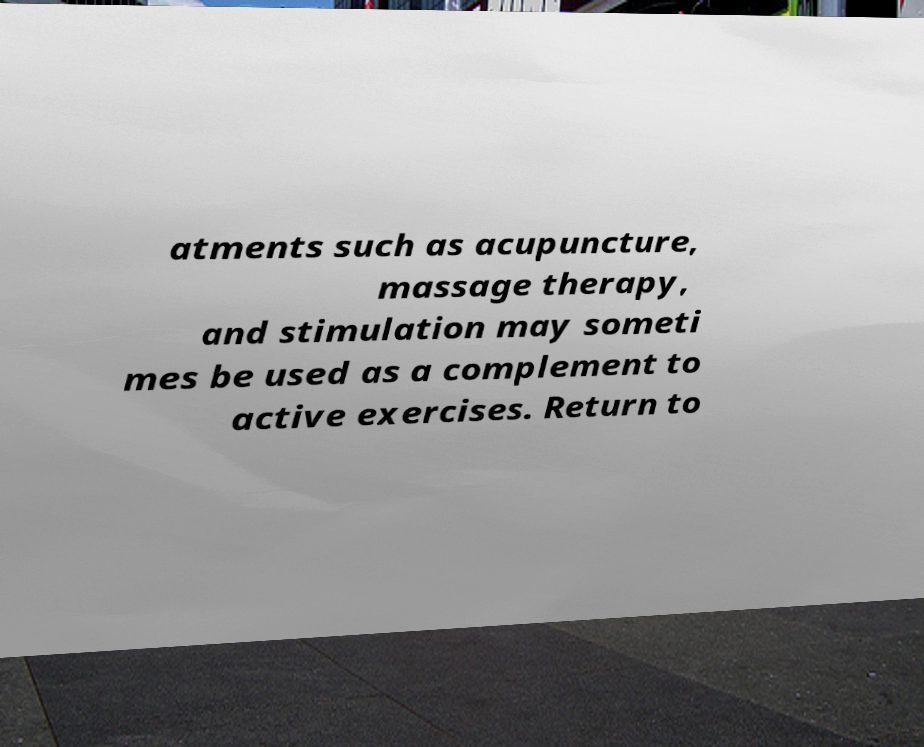Please read and relay the text visible in this image. What does it say? atments such as acupuncture, massage therapy, and stimulation may someti mes be used as a complement to active exercises. Return to 